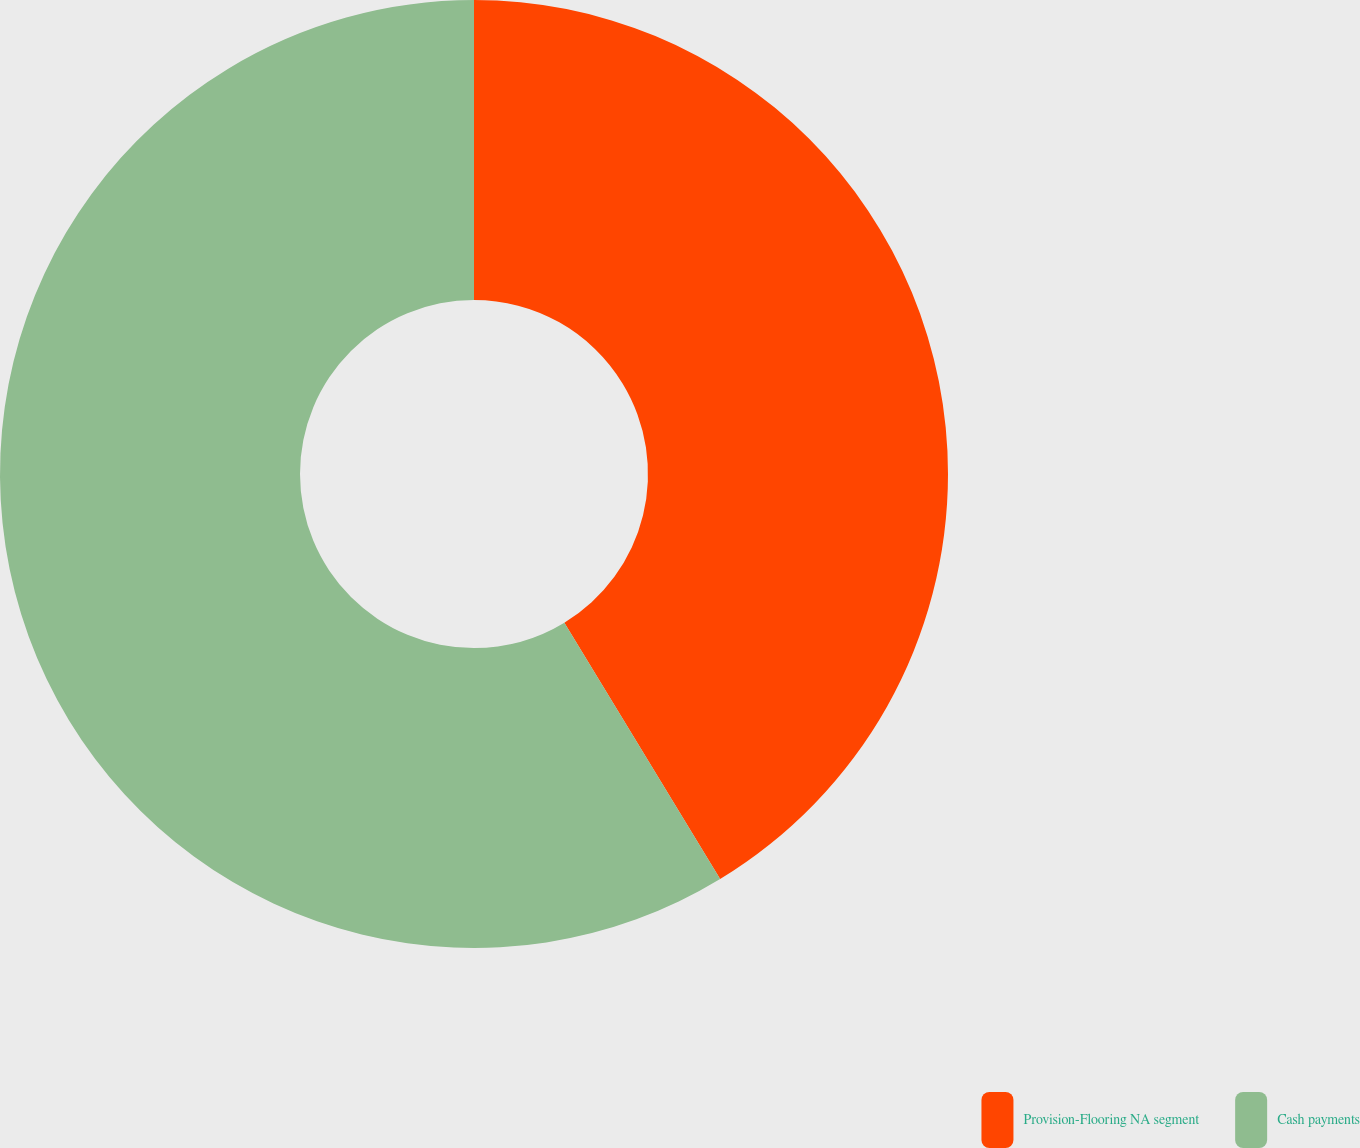<chart> <loc_0><loc_0><loc_500><loc_500><pie_chart><fcel>Provision-Flooring NA segment<fcel>Cash payments<nl><fcel>41.31%<fcel>58.69%<nl></chart> 